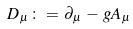Convert formula to latex. <formula><loc_0><loc_0><loc_500><loc_500>D _ { \mu } \, \colon = \, \partial _ { \mu } \, - \, g A _ { \mu }</formula> 